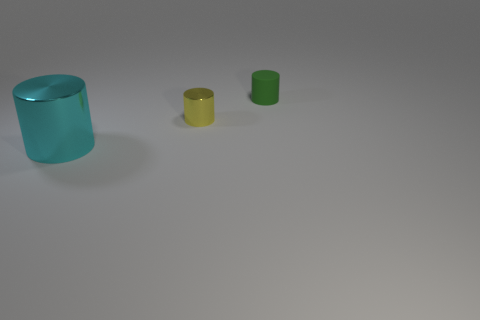Add 1 small matte balls. How many objects exist? 4 Subtract all small cylinders. How many cylinders are left? 1 Subtract all small matte things. Subtract all small yellow metallic cylinders. How many objects are left? 1 Add 3 big cylinders. How many big cylinders are left? 4 Add 1 large yellow matte things. How many large yellow matte things exist? 1 Subtract 0 blue cubes. How many objects are left? 3 Subtract all yellow cylinders. Subtract all brown balls. How many cylinders are left? 2 Subtract all gray blocks. How many blue cylinders are left? 0 